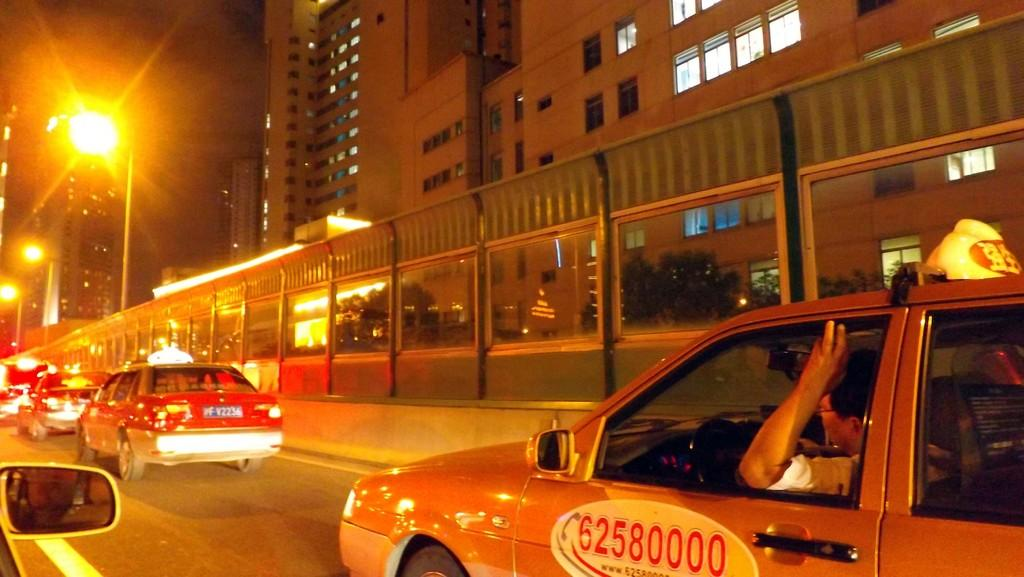<image>
Offer a succinct explanation of the picture presented. The door of a yellow cab displays the number 62580000 on it. 